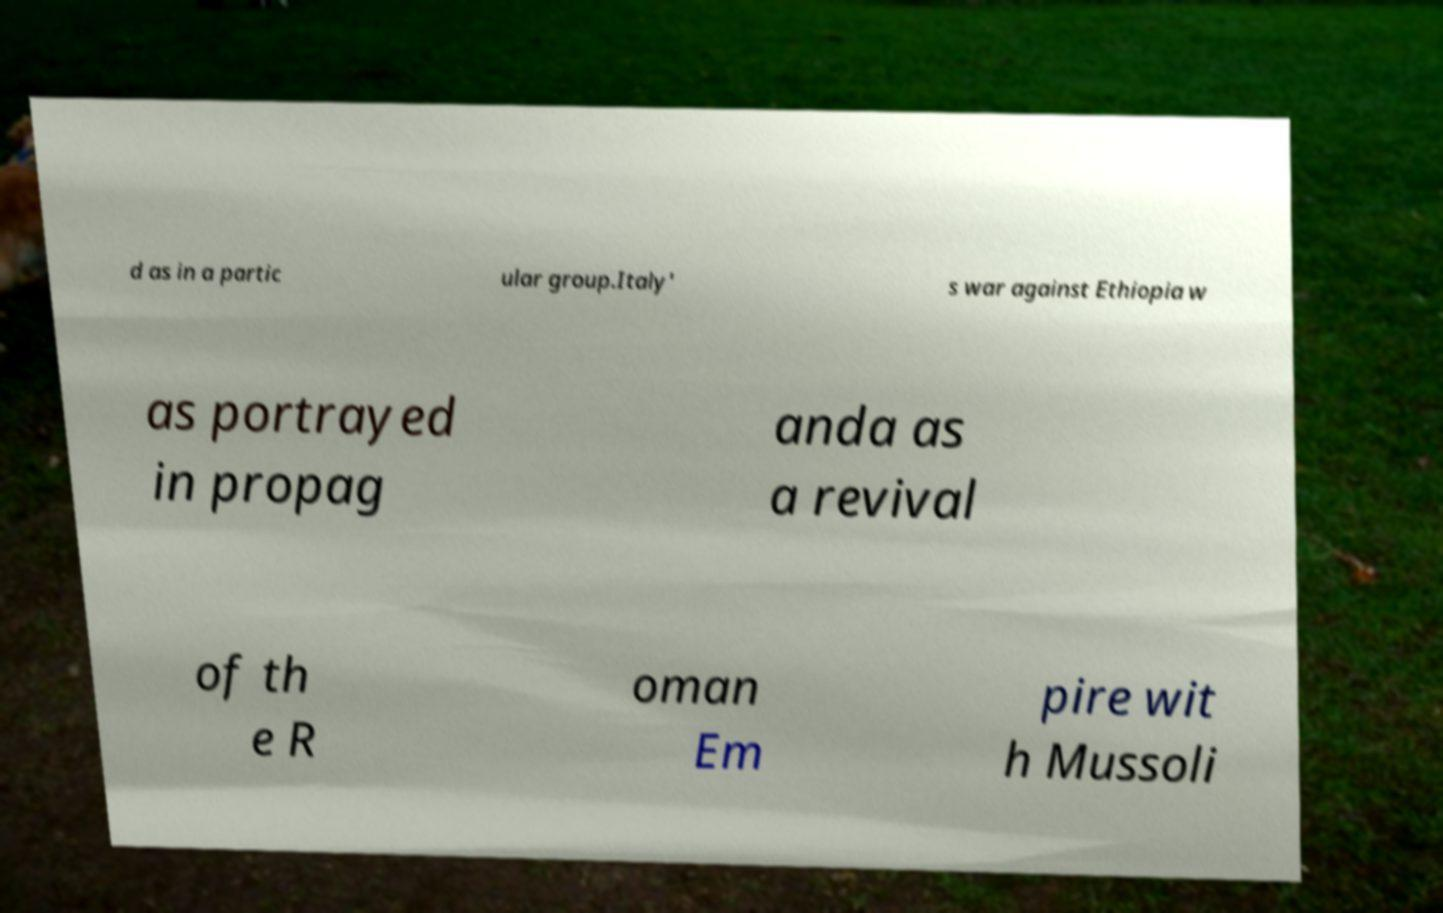For documentation purposes, I need the text within this image transcribed. Could you provide that? d as in a partic ular group.Italy' s war against Ethiopia w as portrayed in propag anda as a revival of th e R oman Em pire wit h Mussoli 